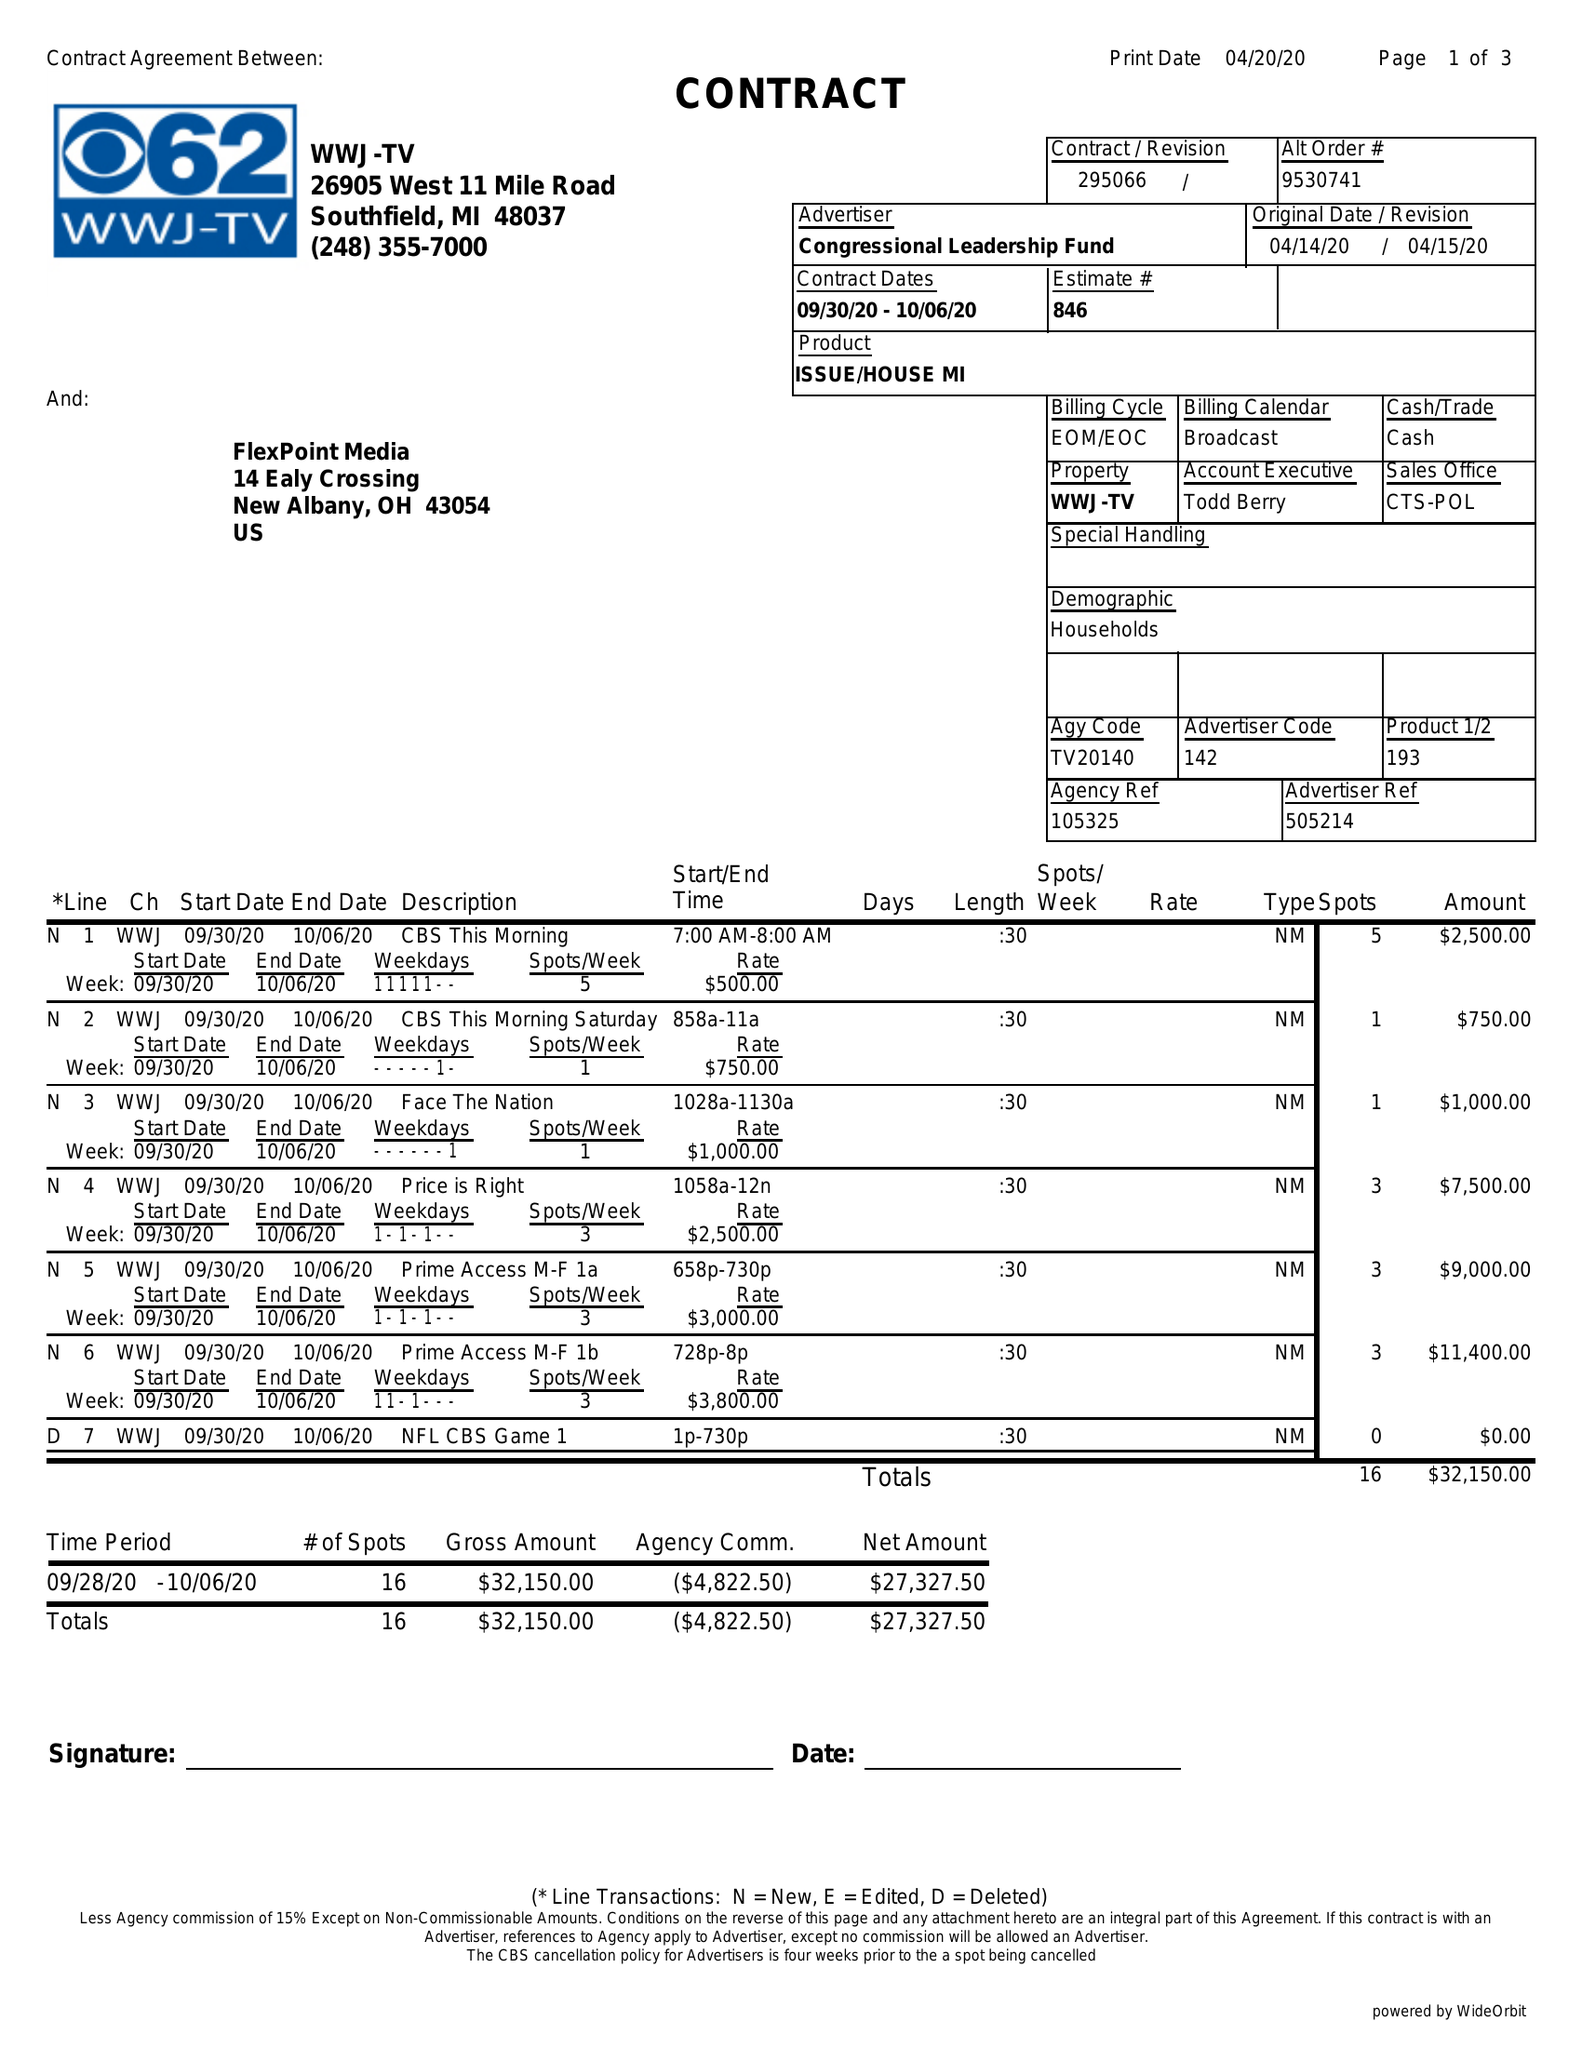What is the value for the flight_from?
Answer the question using a single word or phrase. 09/30/20 